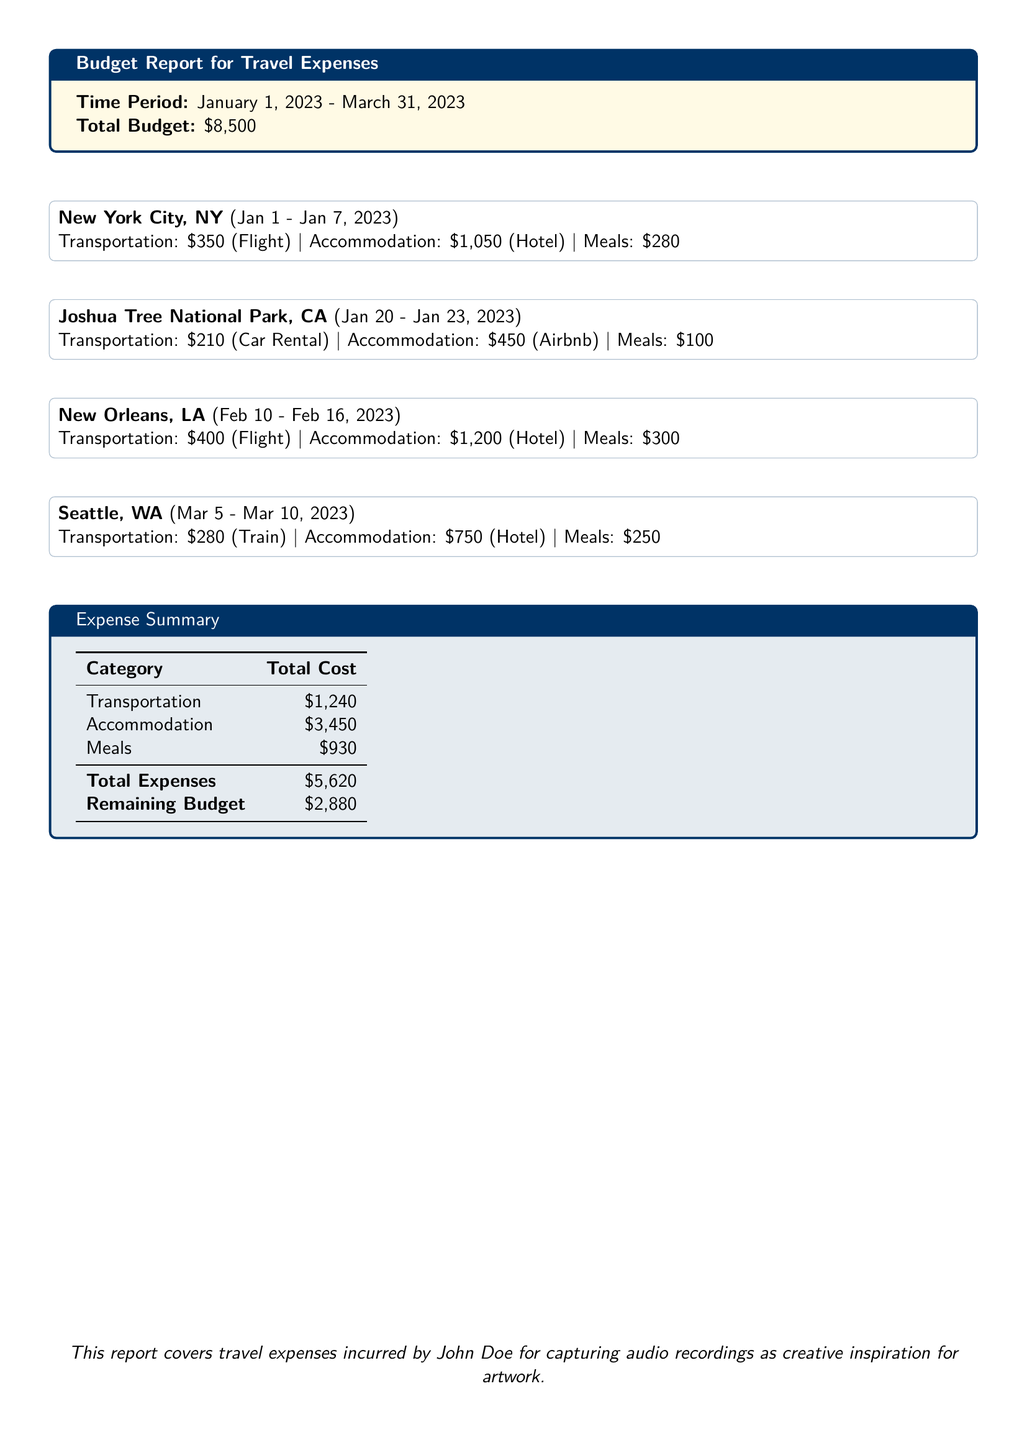What is the total budget? The total budget is stated at the beginning of the document.
Answer: $8,500 How much was spent on transportation? The total cost of transportation is listed in the expense summary.
Answer: $1,240 What city had the highest accommodation cost? The accommodation costs for each city are listed, and New Orleans had the highest cost.
Answer: New Orleans, LA What were the total meal expenses? The total meal expenses are summarized in the expense summary.
Answer: $930 How many days was the trip to New York City? The duration of the New York City trip is stated in the document.
Answer: 7 days What is the remaining budget after expenses? The remaining budget is provided at the end of the expense summary.
Answer: $2,880 What was the accommodation type in Joshua Tree National Park? The accommodation type is mentioned in the expense details for Joshua Tree.
Answer: Airbnb Which city had the lowest transportation cost? By comparing transportation costs, Joshua Tree had the lowest cost.
Answer: Joshua Tree National Park, CA For which location was the trip completed first? The visit sequence is provided in the document with dates.
Answer: New York City, NY 